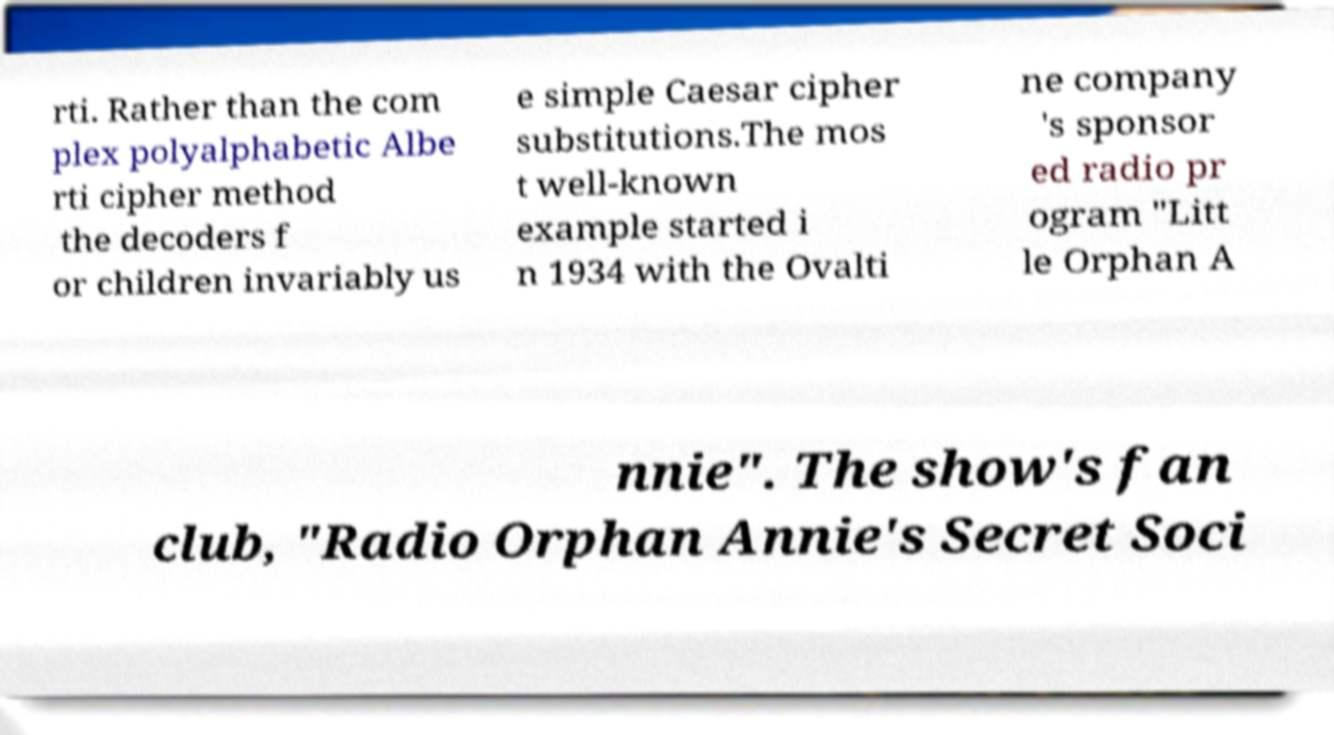I need the written content from this picture converted into text. Can you do that? rti. Rather than the com plex polyalphabetic Albe rti cipher method the decoders f or children invariably us e simple Caesar cipher substitutions.The mos t well-known example started i n 1934 with the Ovalti ne company 's sponsor ed radio pr ogram "Litt le Orphan A nnie". The show's fan club, "Radio Orphan Annie's Secret Soci 